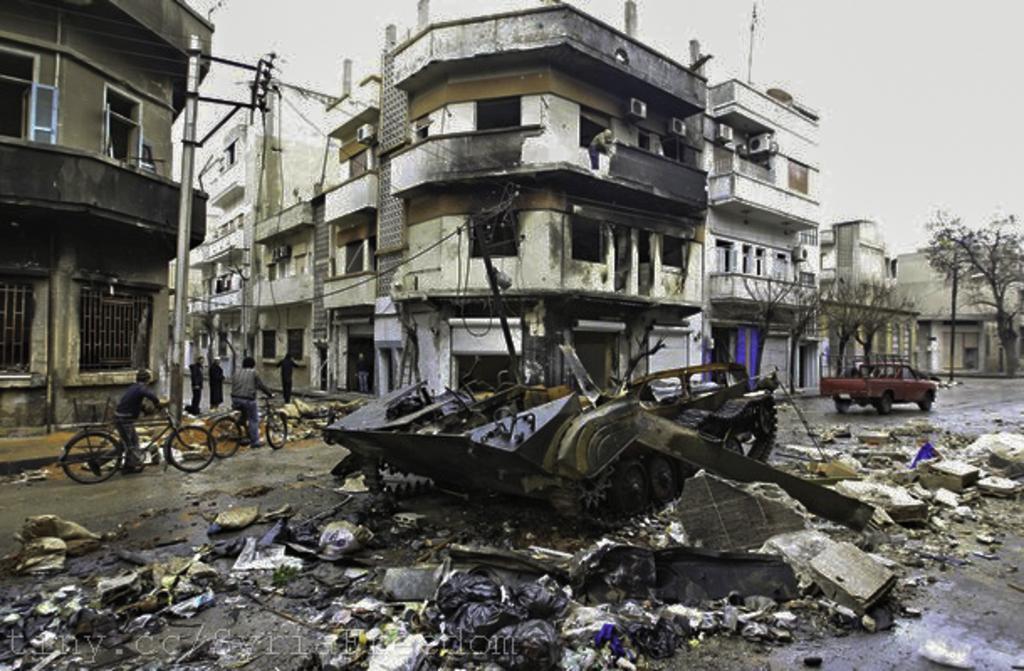Please provide a concise description of this image. In this image, we can see people riding bicycles and some vehicles are on the road and we can see a waste. In the background, there are buildings, trees and poles along with wires and some people standing. 